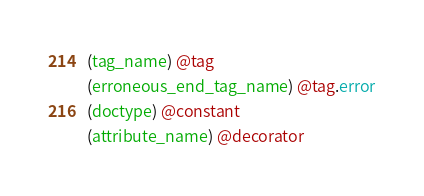<code> <loc_0><loc_0><loc_500><loc_500><_Scheme_>(tag_name) @tag
(erroneous_end_tag_name) @tag.error
(doctype) @constant
(attribute_name) @decorator</code> 